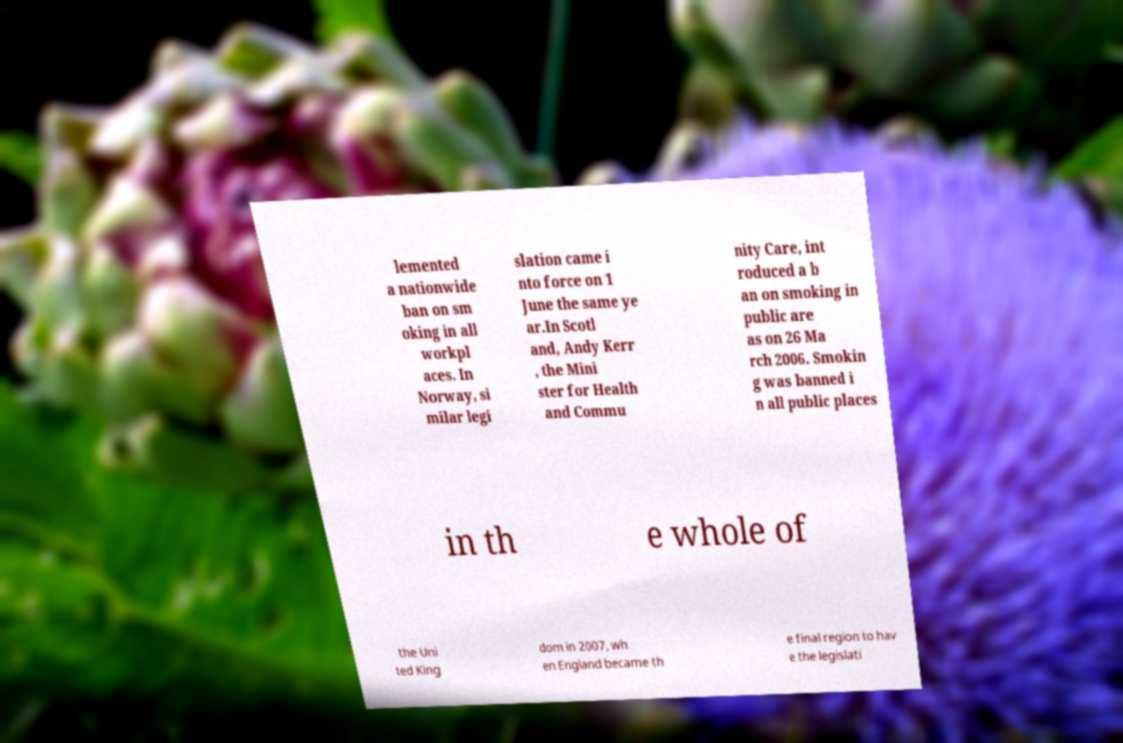Can you accurately transcribe the text from the provided image for me? lemented a nationwide ban on sm oking in all workpl aces. In Norway, si milar legi slation came i nto force on 1 June the same ye ar.In Scotl and, Andy Kerr , the Mini ster for Health and Commu nity Care, int roduced a b an on smoking in public are as on 26 Ma rch 2006. Smokin g was banned i n all public places in th e whole of the Uni ted King dom in 2007, wh en England became th e final region to hav e the legislati 